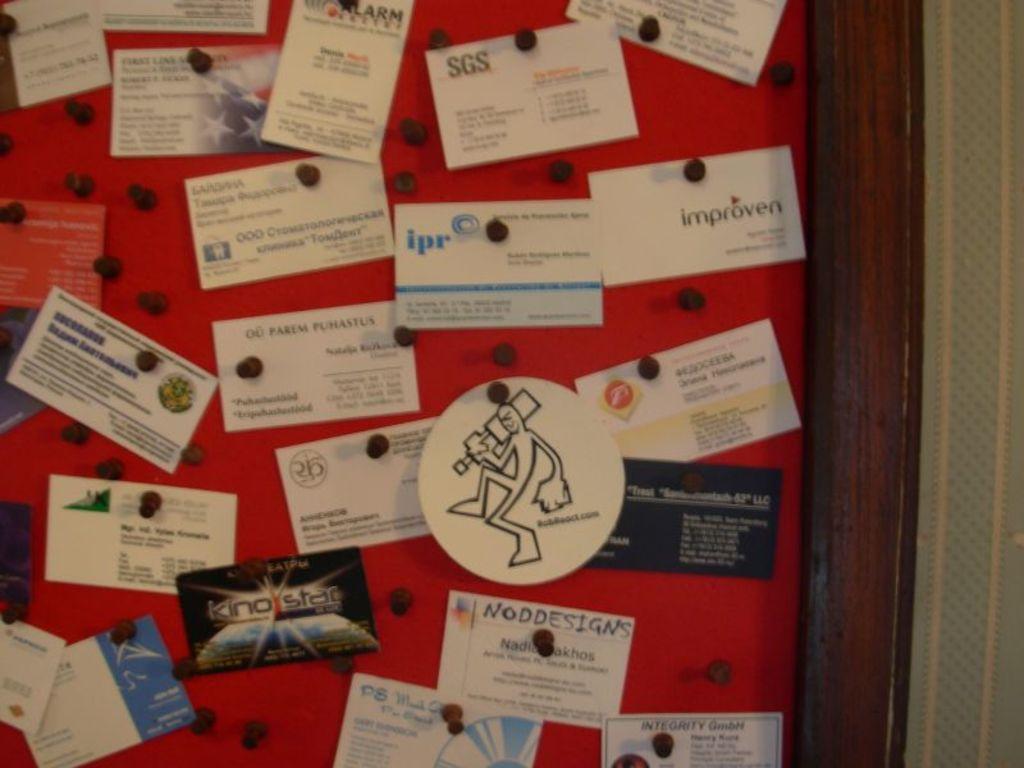What design company's card is that?
Your response must be concise. Unanswerable. Is there an ipr card?
Make the answer very short. Yes. 